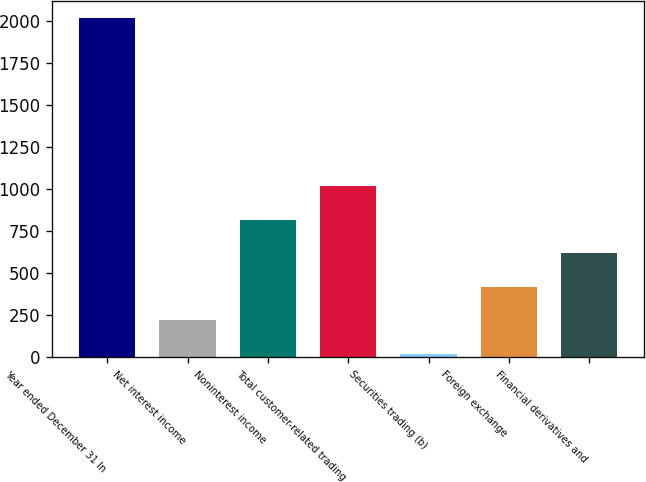Convert chart to OTSL. <chart><loc_0><loc_0><loc_500><loc_500><bar_chart><fcel>Year ended December 31 In<fcel>Net interest income<fcel>Noninterest income<fcel>Total customer-related trading<fcel>Securities trading (b)<fcel>Foreign exchange<fcel>Financial derivatives and<nl><fcel>2013<fcel>220.2<fcel>817.8<fcel>1017<fcel>21<fcel>419.4<fcel>618.6<nl></chart> 